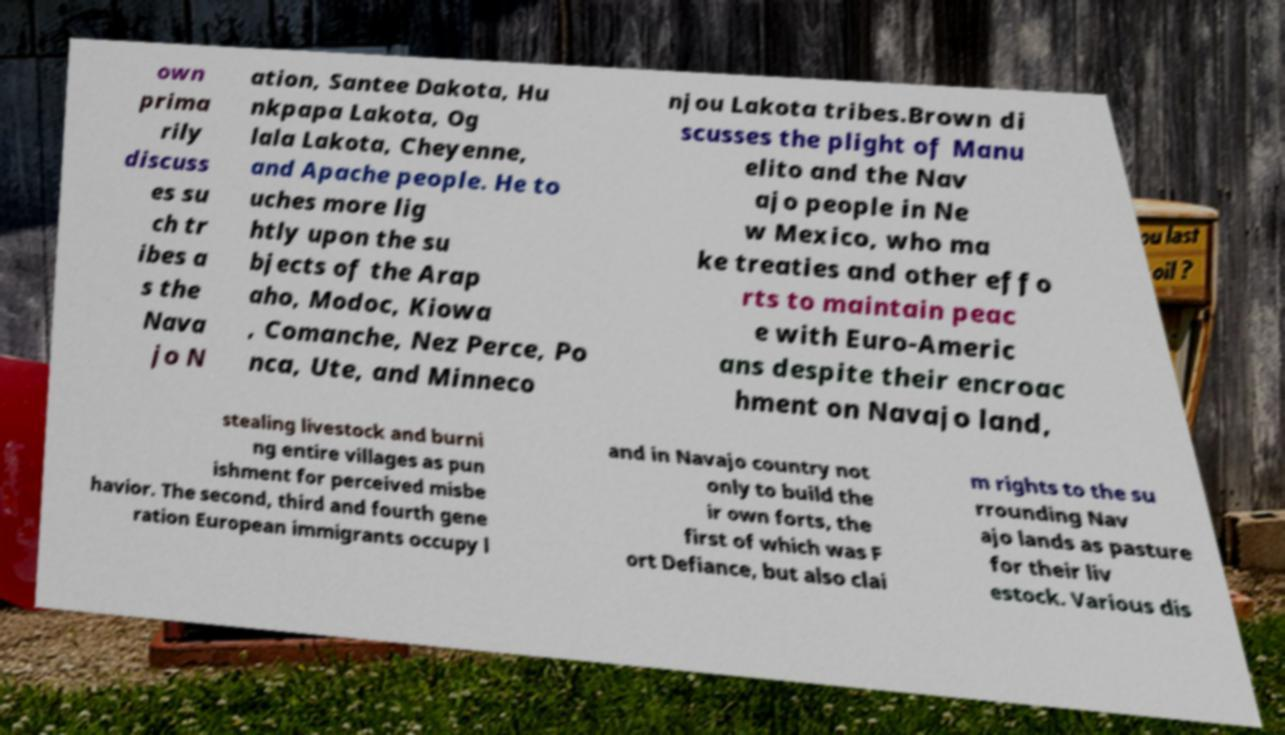Please identify and transcribe the text found in this image. own prima rily discuss es su ch tr ibes a s the Nava jo N ation, Santee Dakota, Hu nkpapa Lakota, Og lala Lakota, Cheyenne, and Apache people. He to uches more lig htly upon the su bjects of the Arap aho, Modoc, Kiowa , Comanche, Nez Perce, Po nca, Ute, and Minneco njou Lakota tribes.Brown di scusses the plight of Manu elito and the Nav ajo people in Ne w Mexico, who ma ke treaties and other effo rts to maintain peac e with Euro-Americ ans despite their encroac hment on Navajo land, stealing livestock and burni ng entire villages as pun ishment for perceived misbe havior. The second, third and fourth gene ration European immigrants occupy l and in Navajo country not only to build the ir own forts, the first of which was F ort Defiance, but also clai m rights to the su rrounding Nav ajo lands as pasture for their liv estock. Various dis 